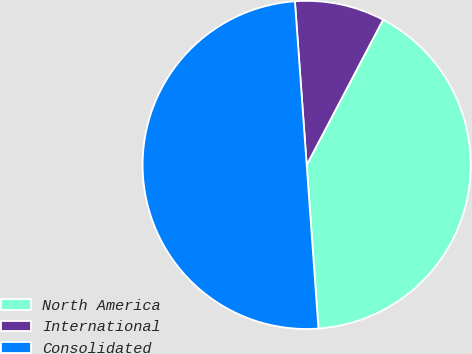<chart> <loc_0><loc_0><loc_500><loc_500><pie_chart><fcel>North America<fcel>International<fcel>Consolidated<nl><fcel>41.15%<fcel>8.85%<fcel>50.0%<nl></chart> 